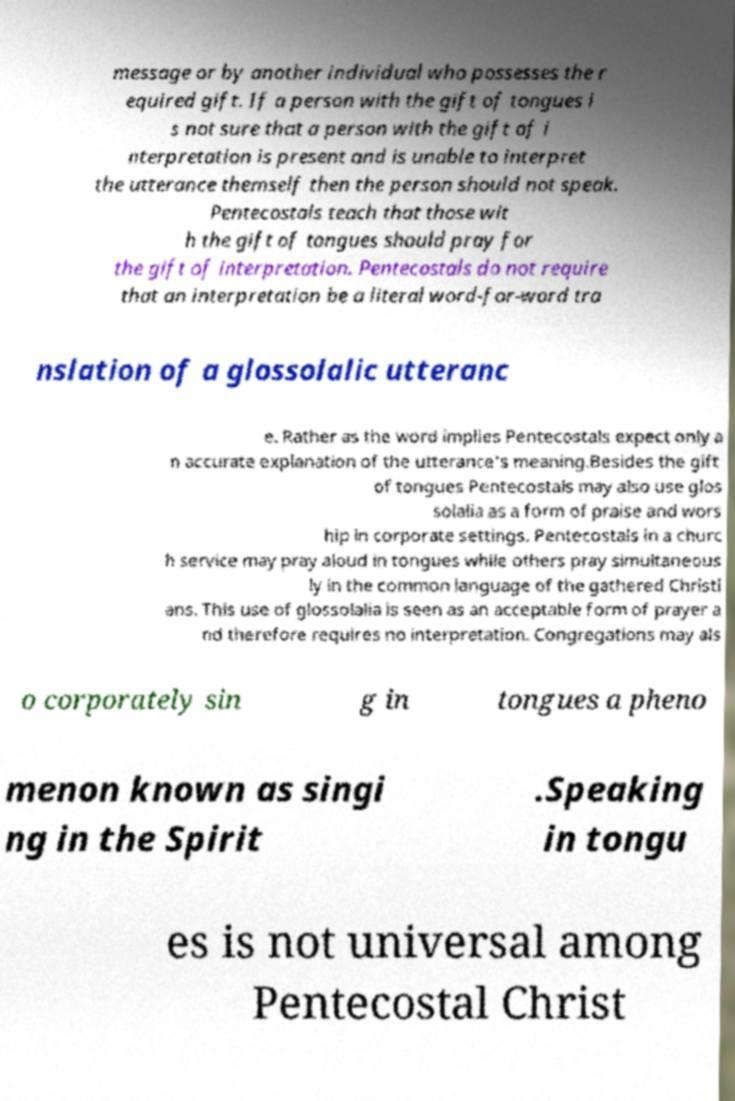Please identify and transcribe the text found in this image. message or by another individual who possesses the r equired gift. If a person with the gift of tongues i s not sure that a person with the gift of i nterpretation is present and is unable to interpret the utterance themself then the person should not speak. Pentecostals teach that those wit h the gift of tongues should pray for the gift of interpretation. Pentecostals do not require that an interpretation be a literal word-for-word tra nslation of a glossolalic utteranc e. Rather as the word implies Pentecostals expect only a n accurate explanation of the utterance's meaning.Besides the gift of tongues Pentecostals may also use glos solalia as a form of praise and wors hip in corporate settings. Pentecostals in a churc h service may pray aloud in tongues while others pray simultaneous ly in the common language of the gathered Christi ans. This use of glossolalia is seen as an acceptable form of prayer a nd therefore requires no interpretation. Congregations may als o corporately sin g in tongues a pheno menon known as singi ng in the Spirit .Speaking in tongu es is not universal among Pentecostal Christ 